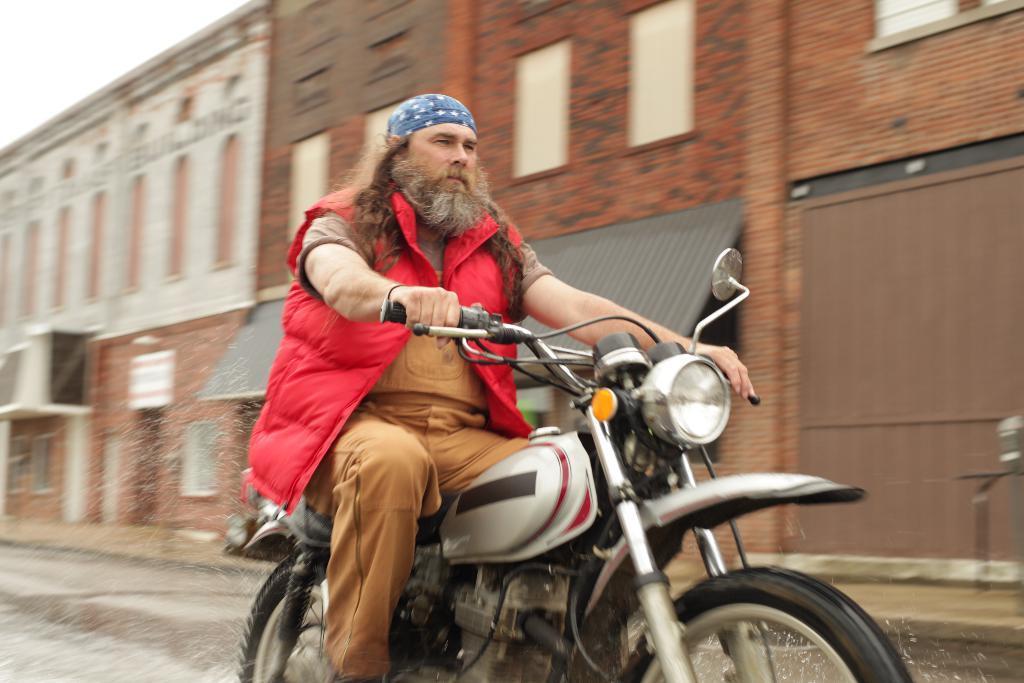In one or two sentences, can you explain what this image depicts? In this picture a man is riding a two wheeler and in the backdrop there is building and the sky is clear 